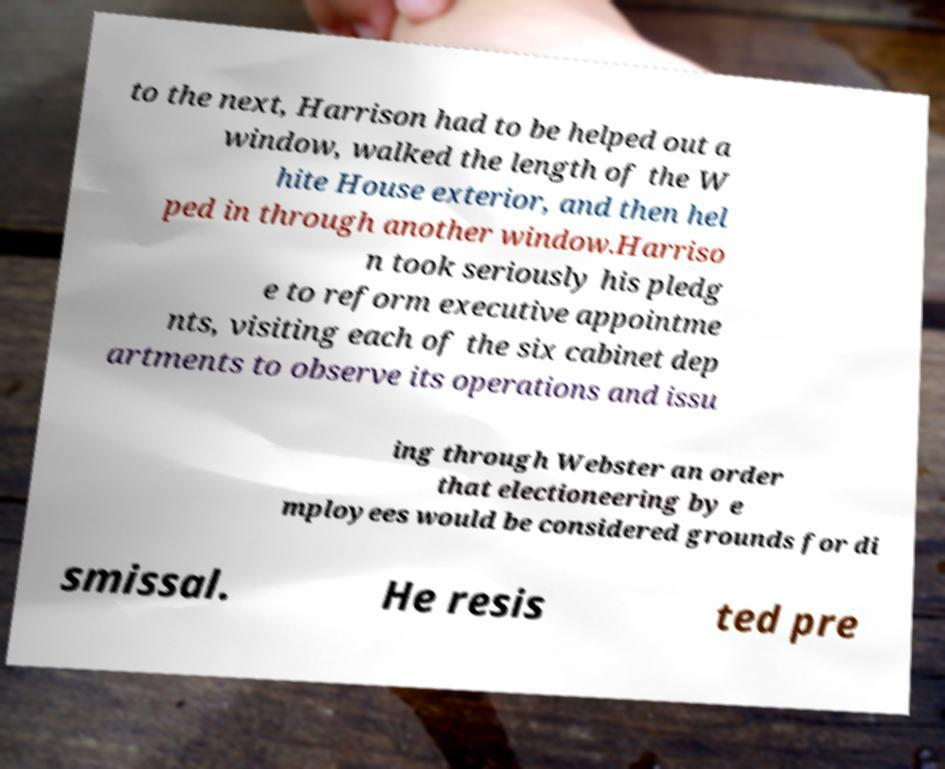Please read and relay the text visible in this image. What does it say? to the next, Harrison had to be helped out a window, walked the length of the W hite House exterior, and then hel ped in through another window.Harriso n took seriously his pledg e to reform executive appointme nts, visiting each of the six cabinet dep artments to observe its operations and issu ing through Webster an order that electioneering by e mployees would be considered grounds for di smissal. He resis ted pre 